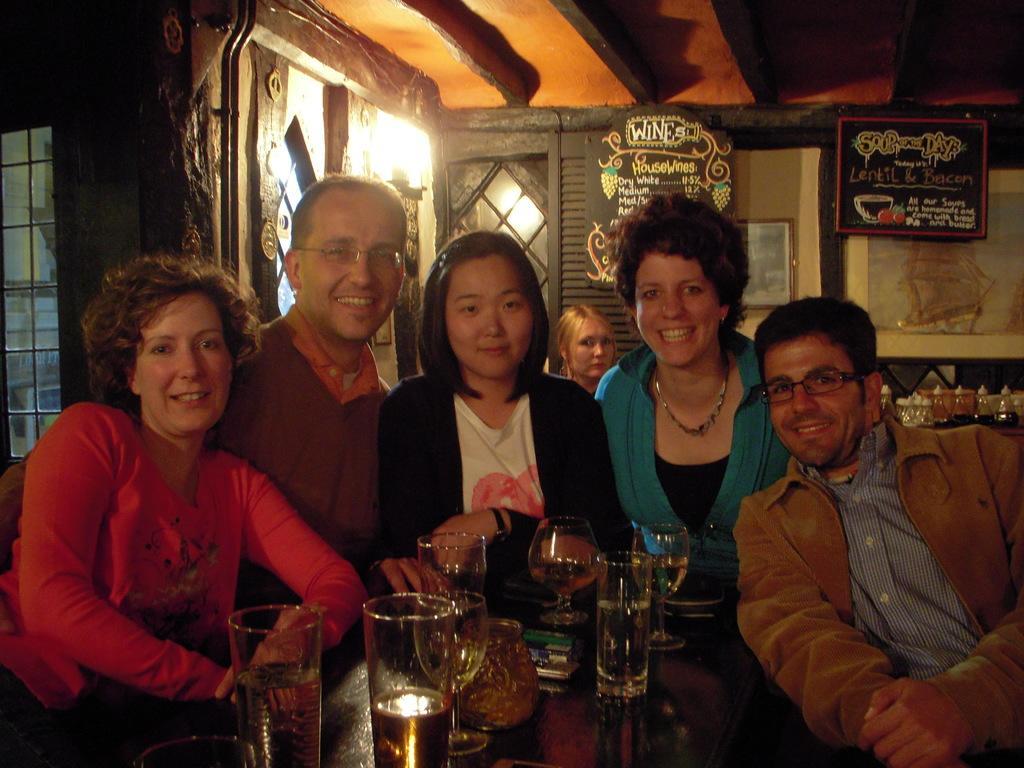Can you describe this image briefly? In this image, we can see a group of people. They are watching. Few are smiling. At the bottom, there is a table, few glasses with liquid and objects are placed on it. Background we can see wall, posters, photo frame, door, glass, grills and light. Top of the image, there is a ceiling. 